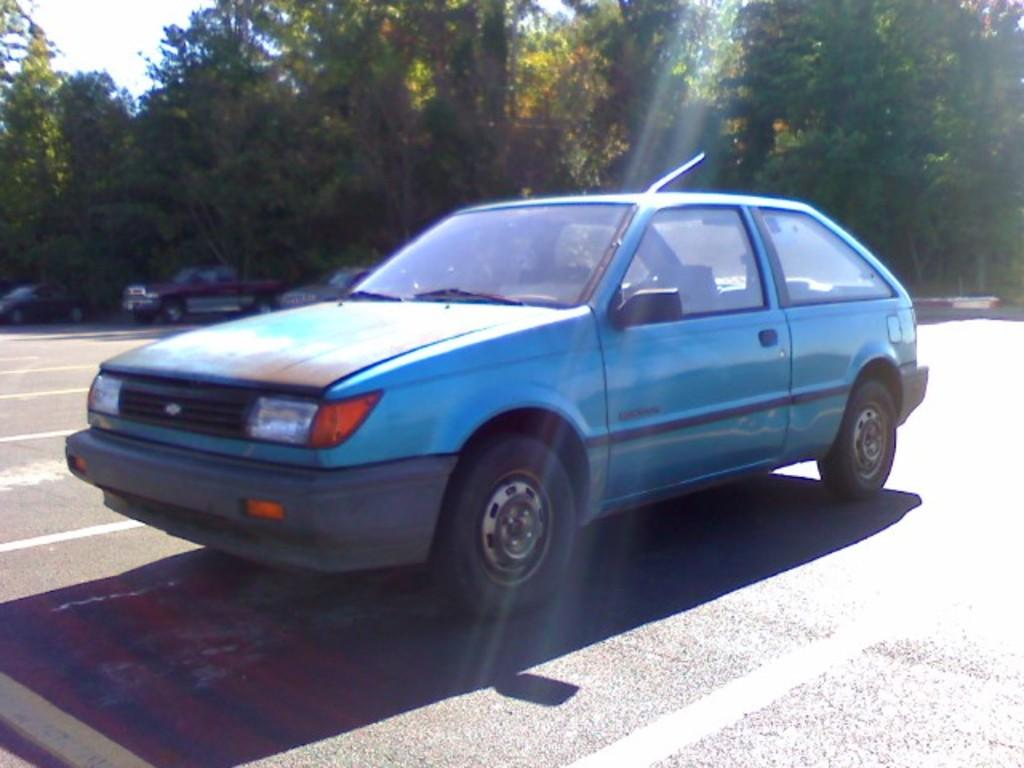What type of vehicles can be seen in the image? There are cars in the image. What are the cars doing in the image? The cars are parked. What type of vegetation is present in the image? There are trees with branches and leaves in the image. Can you tell me how many eggs are on the branches of the trees in the image? There are no eggs present on the branches of the trees in the image; only leaves and branches can be seen. 